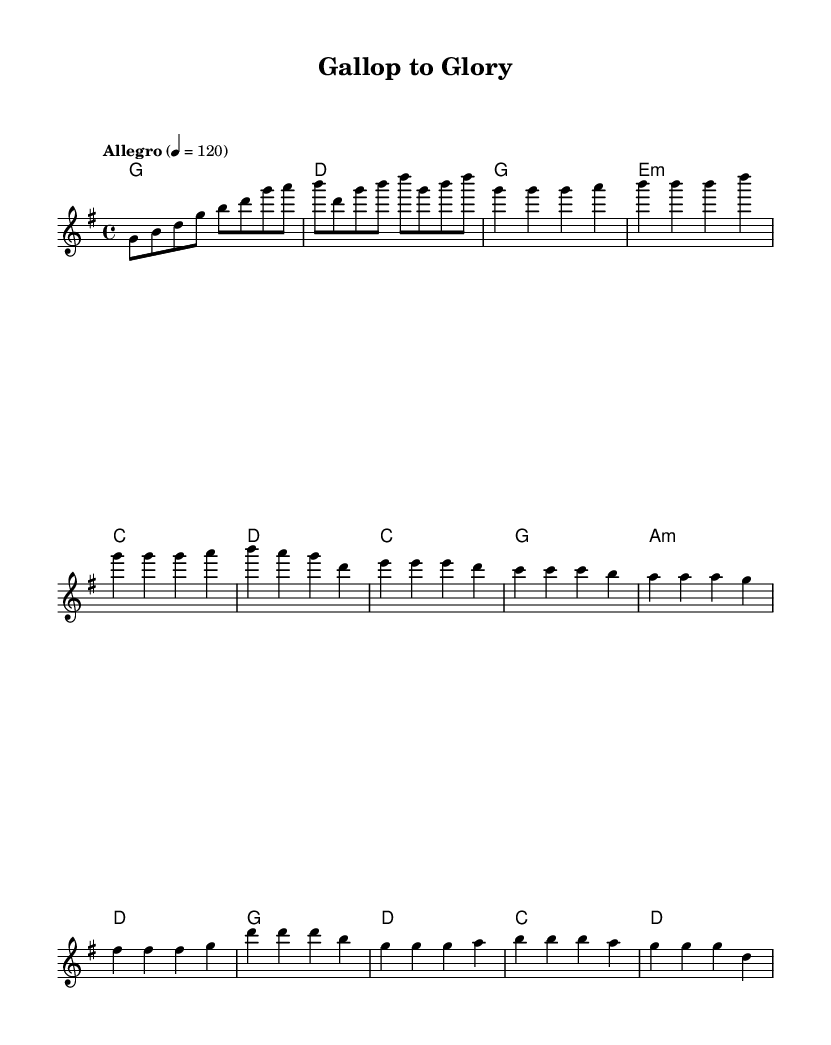What is the key signature of this music? The key signature indicated in the music is G major, which has one sharp (F#). This can be determined by looking at the key signature notation at the beginning of the staff.
Answer: G major What is the time signature of this piece? The time signature shown at the beginning of the score is 4/4, which means there are four beats in each measure, and the quarter note receives one beat. This is indicated numerically near the beginning of the sheet music.
Answer: 4/4 What is the tempo marking for this piece? The tempo marking at the beginning states "Allegro" with a metronome mark of 120 beats per minute. This indicates a lively and fast pace for the piece. This information is clearly noted at the beginning of the score.
Answer: Allegro, 120 Which section follows the chorus? The structure of the song typically includes an introduction, verse, pre-chorus, and chorus. Since the provided music does not include a designation for a section following the chorus, but rather concludes with the chorus, it suggests that the piece may be cyclical or end here.
Answer: None How many measures are in the verse section? The verse section consists of four measures, as indicated by the grouping of music notes marked specifically for the verse. Counting each line of the music after the introduction indicates this clearly.
Answer: 4 What is the harmonic progression for the chorus? The harmonic progression in the chorus follows the chords: G, D, C, and D as indicated by the harmony part below the melody. This succession of chords can be analyzed from the chord symbols located there.
Answer: G, D, C, D 